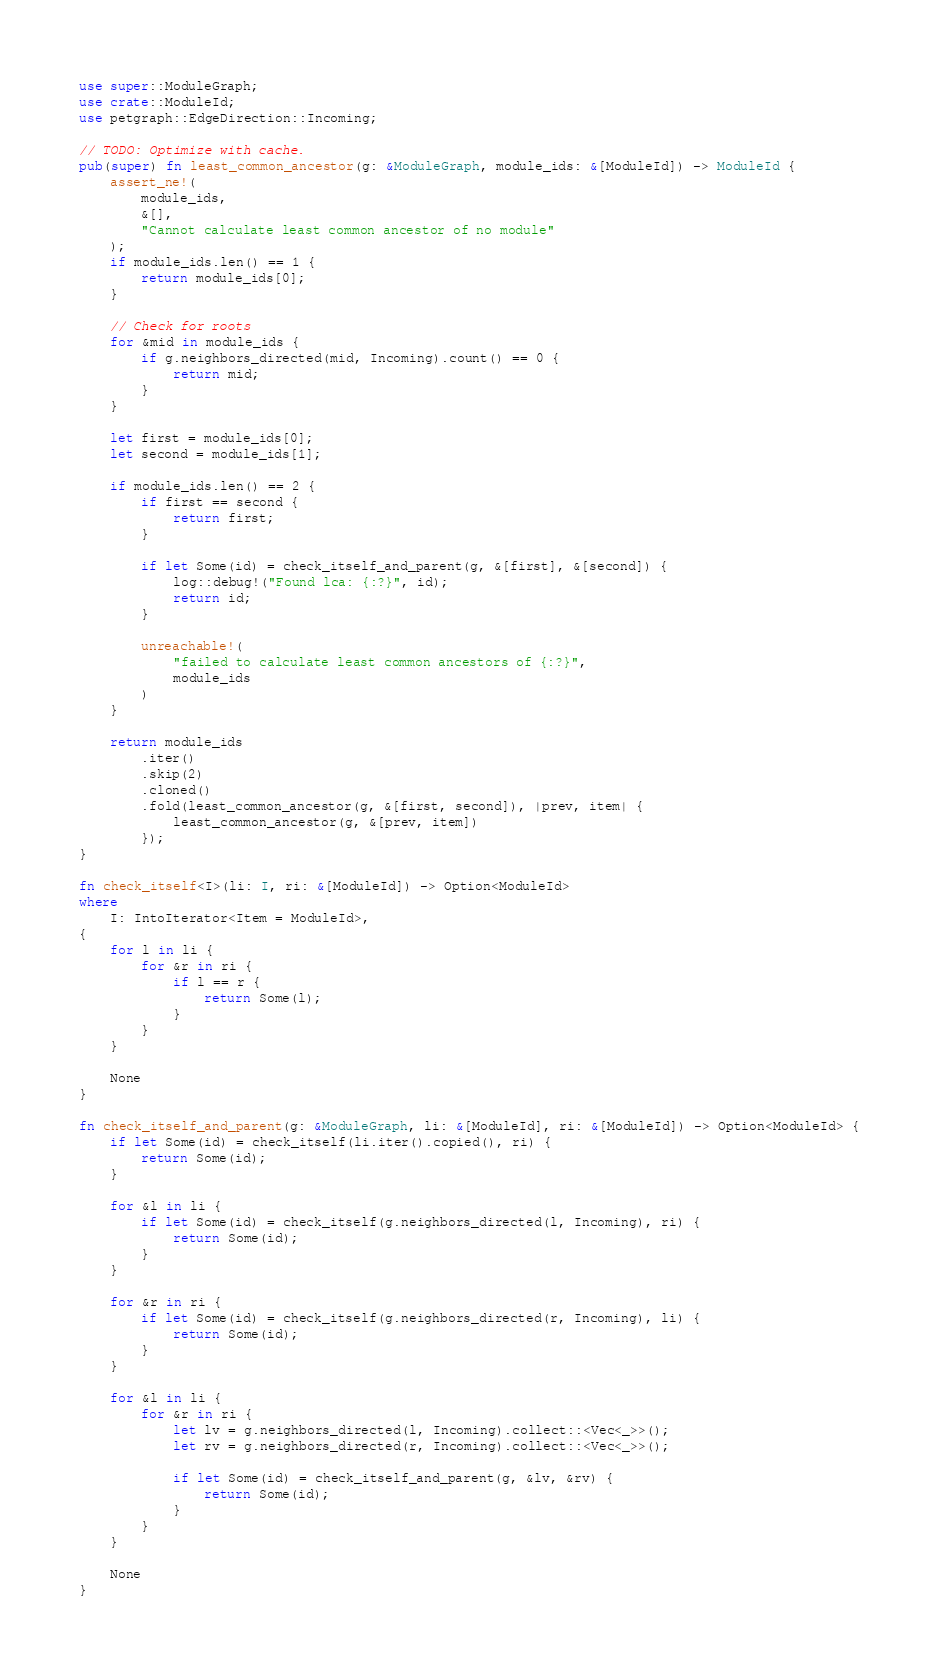<code> <loc_0><loc_0><loc_500><loc_500><_Rust_>use super::ModuleGraph;
use crate::ModuleId;
use petgraph::EdgeDirection::Incoming;

// TODO: Optimize with cache.
pub(super) fn least_common_ancestor(g: &ModuleGraph, module_ids: &[ModuleId]) -> ModuleId {
    assert_ne!(
        module_ids,
        &[],
        "Cannot calculate least common ancestor of no module"
    );
    if module_ids.len() == 1 {
        return module_ids[0];
    }

    // Check for roots
    for &mid in module_ids {
        if g.neighbors_directed(mid, Incoming).count() == 0 {
            return mid;
        }
    }

    let first = module_ids[0];
    let second = module_ids[1];

    if module_ids.len() == 2 {
        if first == second {
            return first;
        }

        if let Some(id) = check_itself_and_parent(g, &[first], &[second]) {
            log::debug!("Found lca: {:?}", id);
            return id;
        }

        unreachable!(
            "failed to calculate least common ancestors of {:?}",
            module_ids
        )
    }

    return module_ids
        .iter()
        .skip(2)
        .cloned()
        .fold(least_common_ancestor(g, &[first, second]), |prev, item| {
            least_common_ancestor(g, &[prev, item])
        });
}

fn check_itself<I>(li: I, ri: &[ModuleId]) -> Option<ModuleId>
where
    I: IntoIterator<Item = ModuleId>,
{
    for l in li {
        for &r in ri {
            if l == r {
                return Some(l);
            }
        }
    }

    None
}

fn check_itself_and_parent(g: &ModuleGraph, li: &[ModuleId], ri: &[ModuleId]) -> Option<ModuleId> {
    if let Some(id) = check_itself(li.iter().copied(), ri) {
        return Some(id);
    }

    for &l in li {
        if let Some(id) = check_itself(g.neighbors_directed(l, Incoming), ri) {
            return Some(id);
        }
    }

    for &r in ri {
        if let Some(id) = check_itself(g.neighbors_directed(r, Incoming), li) {
            return Some(id);
        }
    }

    for &l in li {
        for &r in ri {
            let lv = g.neighbors_directed(l, Incoming).collect::<Vec<_>>();
            let rv = g.neighbors_directed(r, Incoming).collect::<Vec<_>>();

            if let Some(id) = check_itself_and_parent(g, &lv, &rv) {
                return Some(id);
            }
        }
    }

    None
}
</code> 